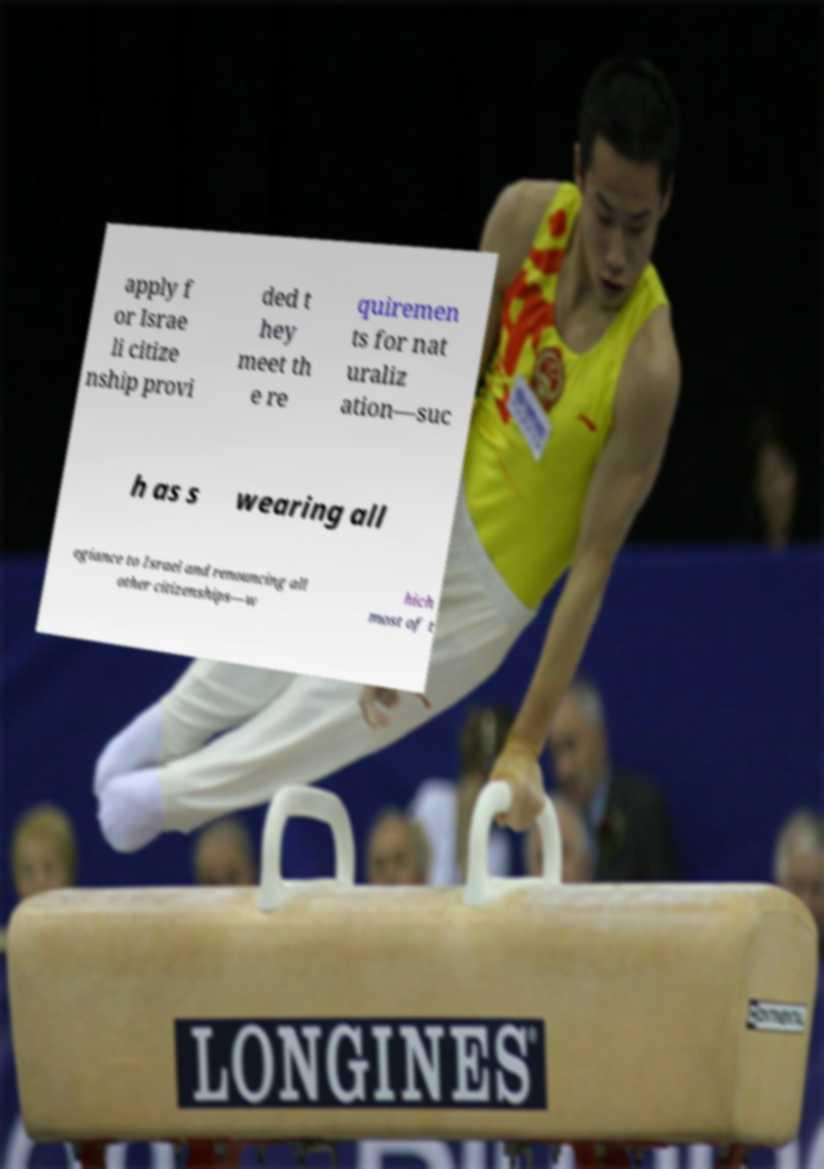What messages or text are displayed in this image? I need them in a readable, typed format. apply f or Israe li citize nship provi ded t hey meet th e re quiremen ts for nat uraliz ation—suc h as s wearing all egiance to Israel and renouncing all other citizenships—w hich most of t 